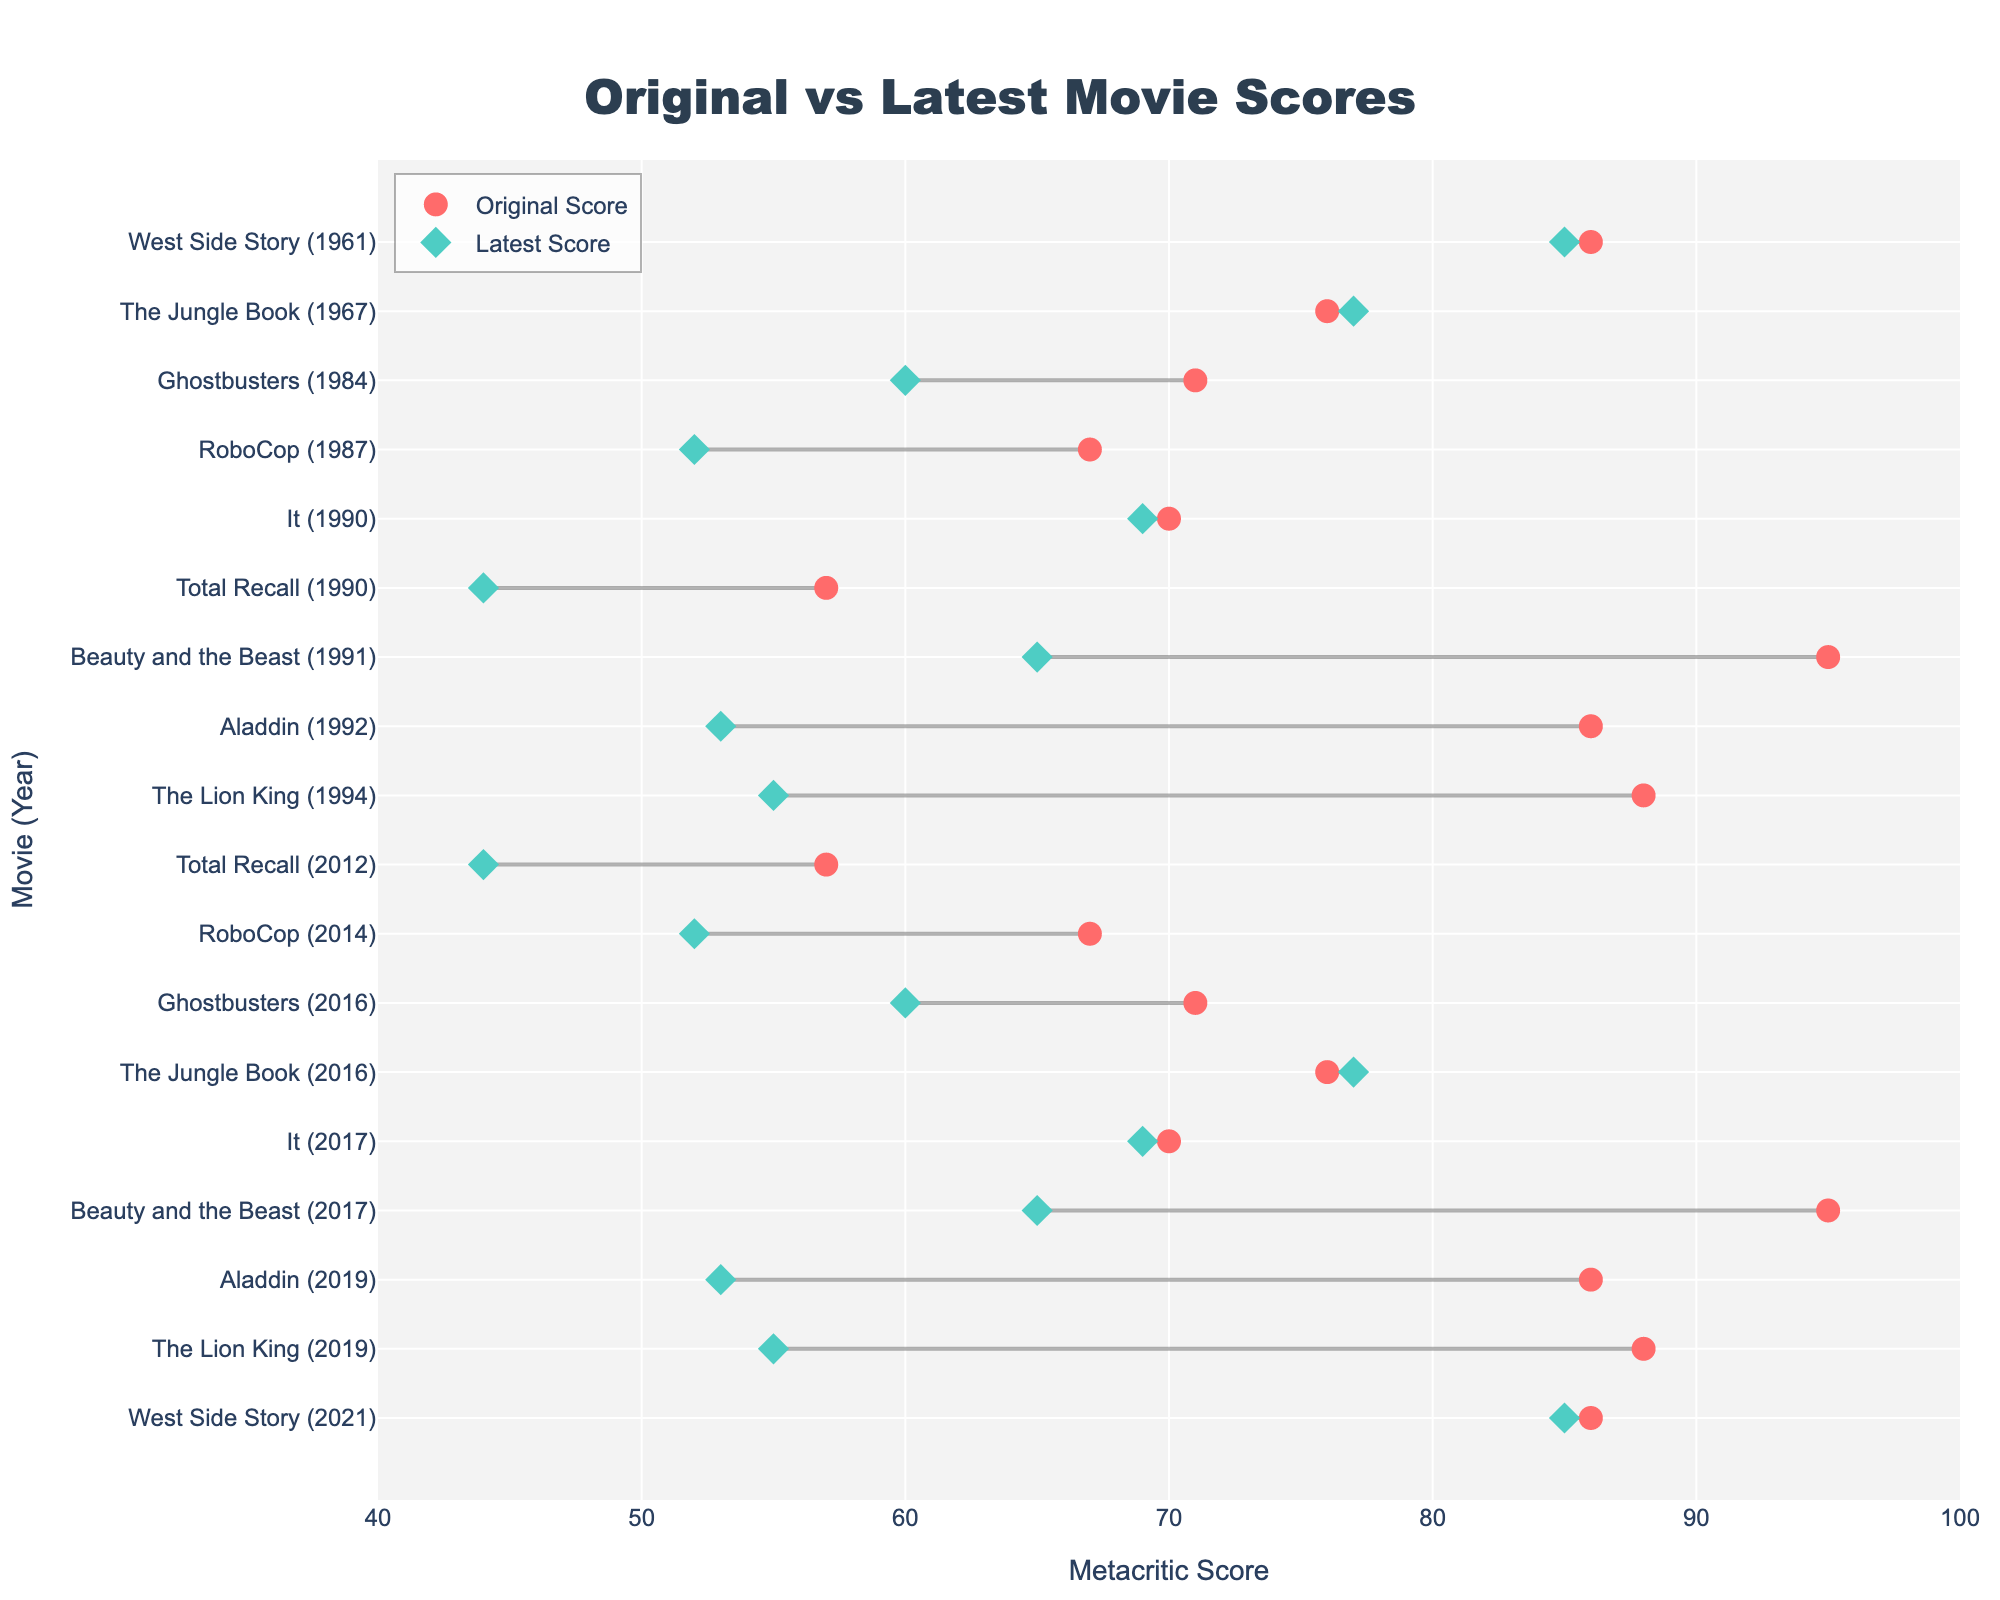What is the title of the plot? The title of the plot is typically found at the top of the figure, centered. In this case, the main header reads "Original vs Latest Movie Scores".
Answer: Original vs Latest Movie Scores Which movies had an increase in their scores from the original version to the latest version? To find this, examine the markers for both the original and latest scores. The lines connecting the markers should slant upwards from left to right in such cases. The movies are "The Jungle Book" and "West Side Story".
Answer: The Jungle Book and West Side Story Which movie has the largest decrease in score from the original to the latest version? Check all the lines representing connected markers and identify the one with the longest distance between the markers from left to right indicating a decrease. "Beauty and the Beast" has a decrease from 95 to 65, which is the largest difference.
Answer: Beauty and the Beast How does "It" compare in terms of score change? Look at the markers for "It" and compare the original and latest scores. Both scores are nearly the same, differing by only 1 point (70 for original and 69 for latest).
Answer: Nearly the same What color represents the latest scores on the plot? Examining the visual markers, the latest scores are displayed with diamond markers that are colored in cyan.
Answer: Cyan Are there any movies where the scores remained exactly the same from the original to the latest version? Check for lines where the markers for original and latest scores are at the same position. Both markers for "The Lion King," "Aladdin," and "It" show no change in their positions.
Answer: The Lion King, Aladdin, and It What is the overall trend in scores from the original to the latest movie versions? Observing the lines connecting the markers, most lines trend downwards, indicating that scores generally decreased from the original to the latest versions.
Answer: Generally decreased Which Movie-Year pair shows the highest original score? Identify the top red circle marker along the horizontal axis, which represents the original scores. "Beauty and the Beast (1991)" has the highest original score of 95.
Answer: Beauty and the Beast (1991) What's the average score of the latest movies? Sum the scores of all the latest movies and divide by the number of movies: (55 + 53 + 65 + 69 + 44 + 60 + 52 + 77 + 85) / 9 = 56.67
Answer: 56.67 